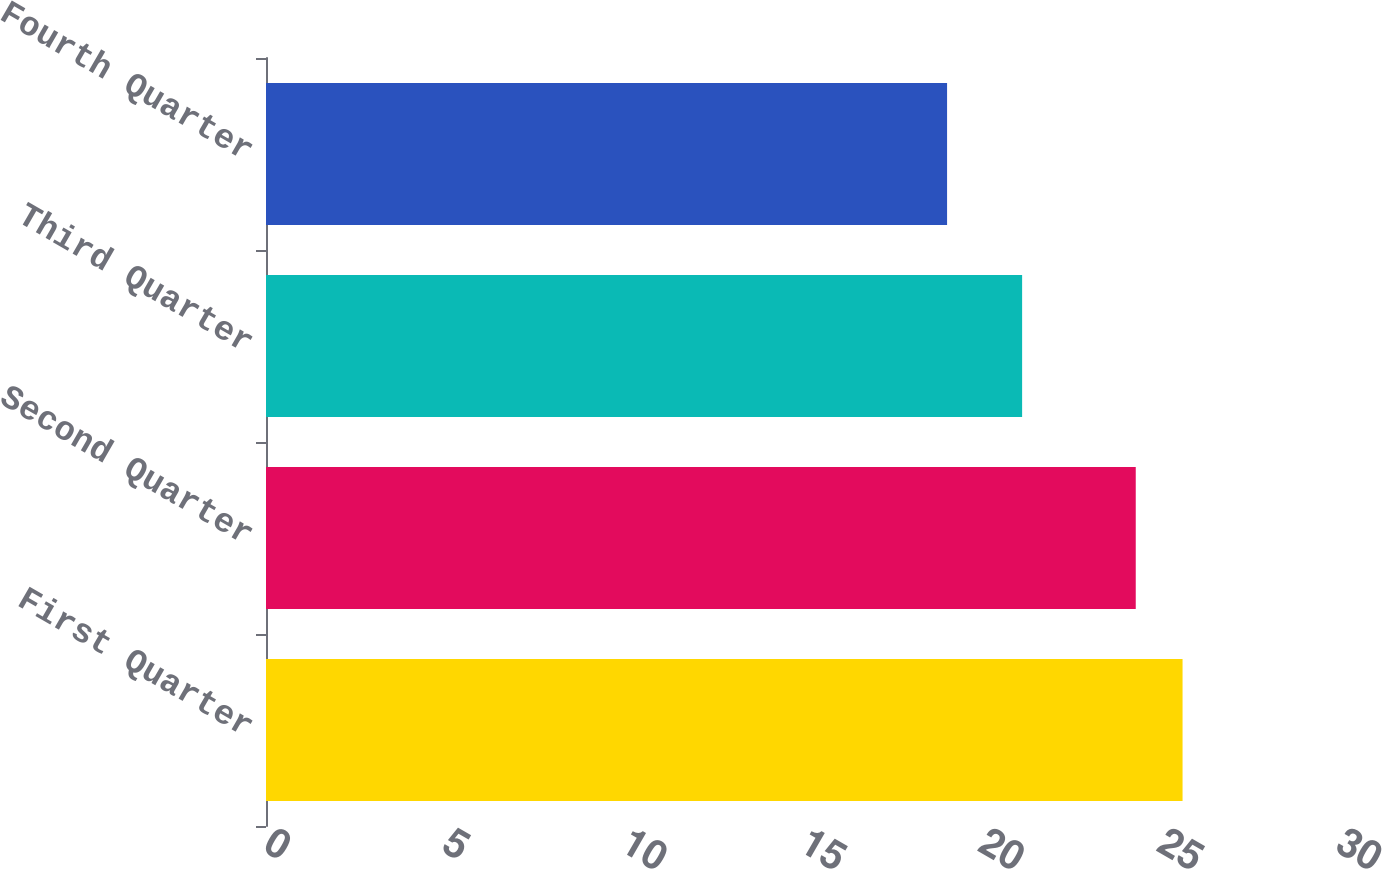Convert chart to OTSL. <chart><loc_0><loc_0><loc_500><loc_500><bar_chart><fcel>First Quarter<fcel>Second Quarter<fcel>Third Quarter<fcel>Fourth Quarter<nl><fcel>25.65<fcel>24.34<fcel>21.16<fcel>19.06<nl></chart> 